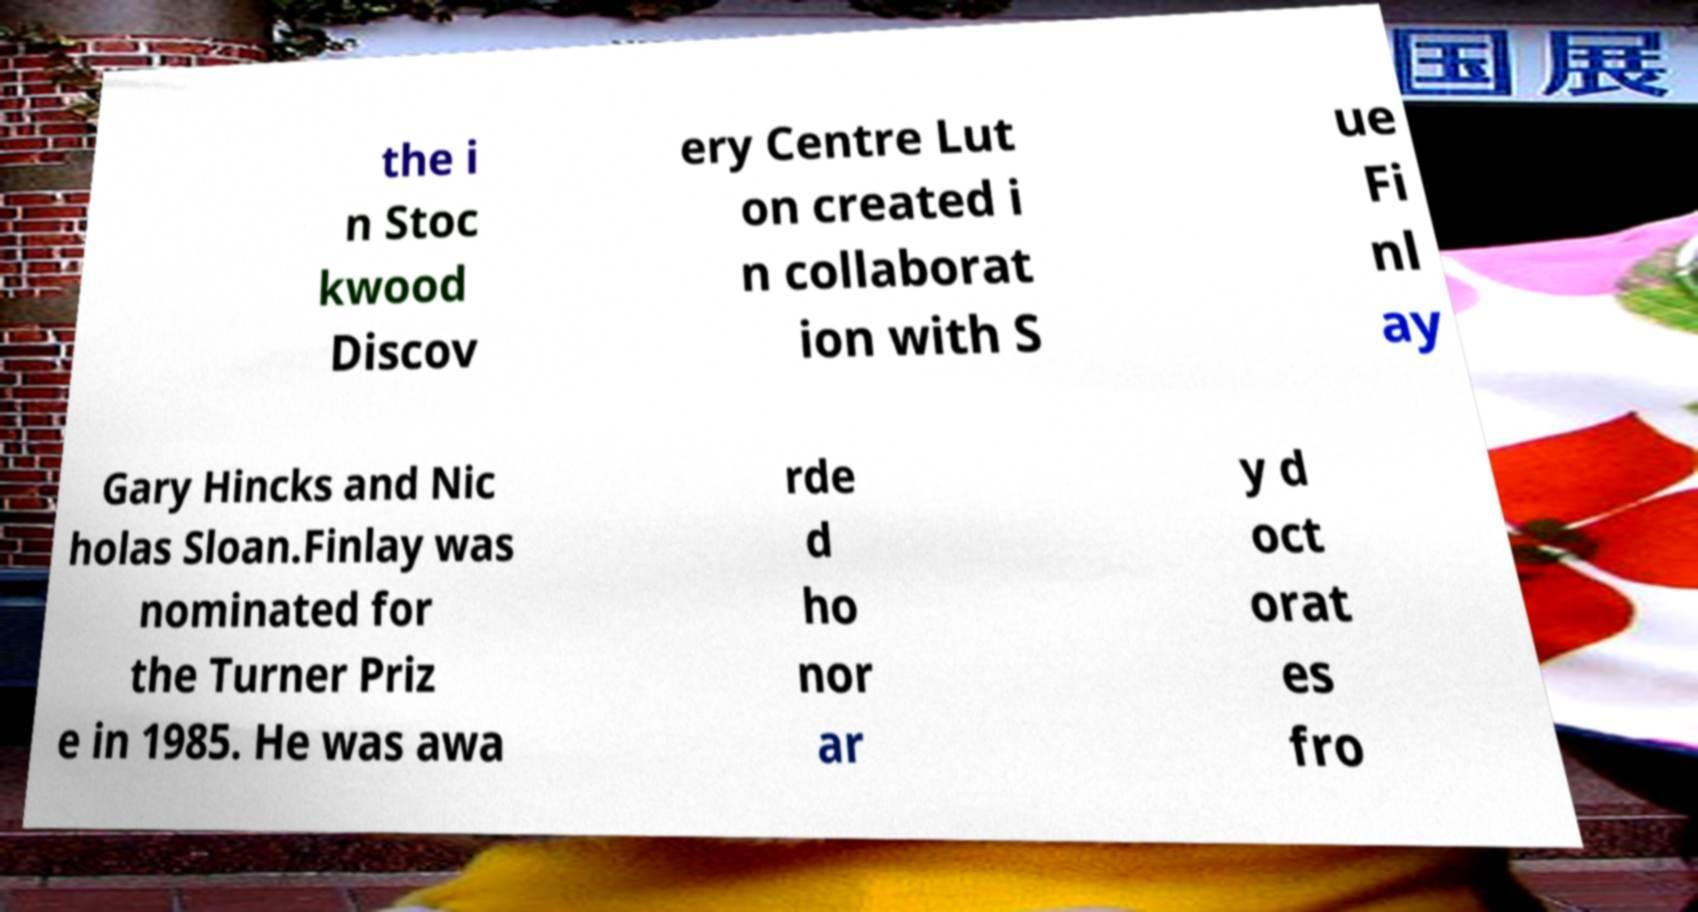Please identify and transcribe the text found in this image. the i n Stoc kwood Discov ery Centre Lut on created i n collaborat ion with S ue Fi nl ay Gary Hincks and Nic holas Sloan.Finlay was nominated for the Turner Priz e in 1985. He was awa rde d ho nor ar y d oct orat es fro 